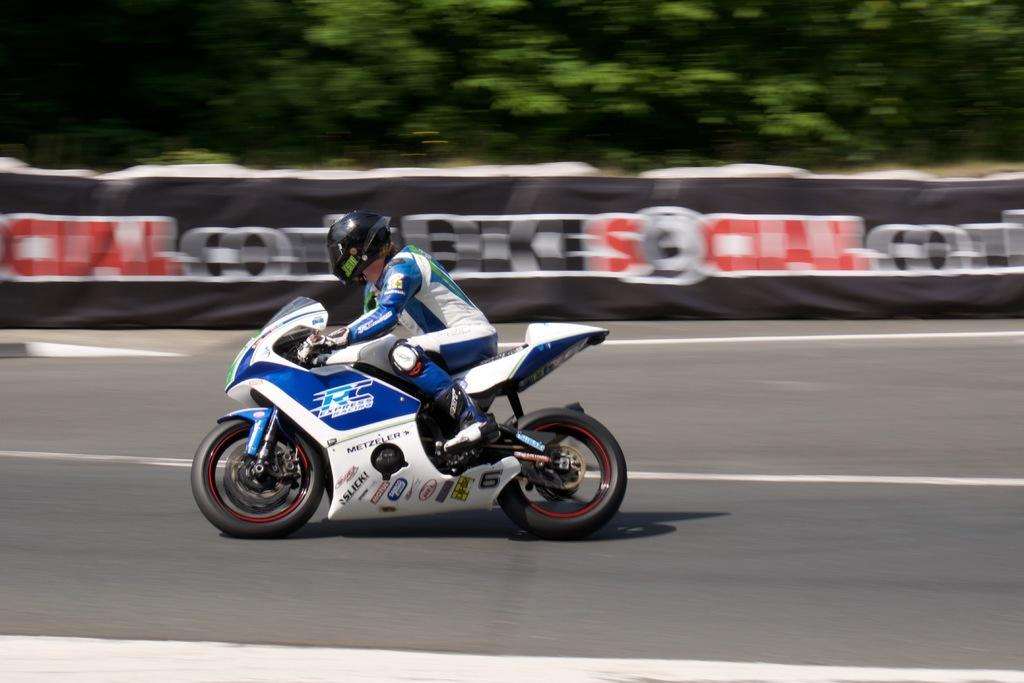What is the main subject of the image? There is a person riding a bike in the image. What can be seen in the background of the image? There is a banner with text and trees in the background of the image. Where is the pot located in the image? There is no pot present in the image. What type of bee can be seen flying near the person riding the bike? There are no bees visible in the image. 